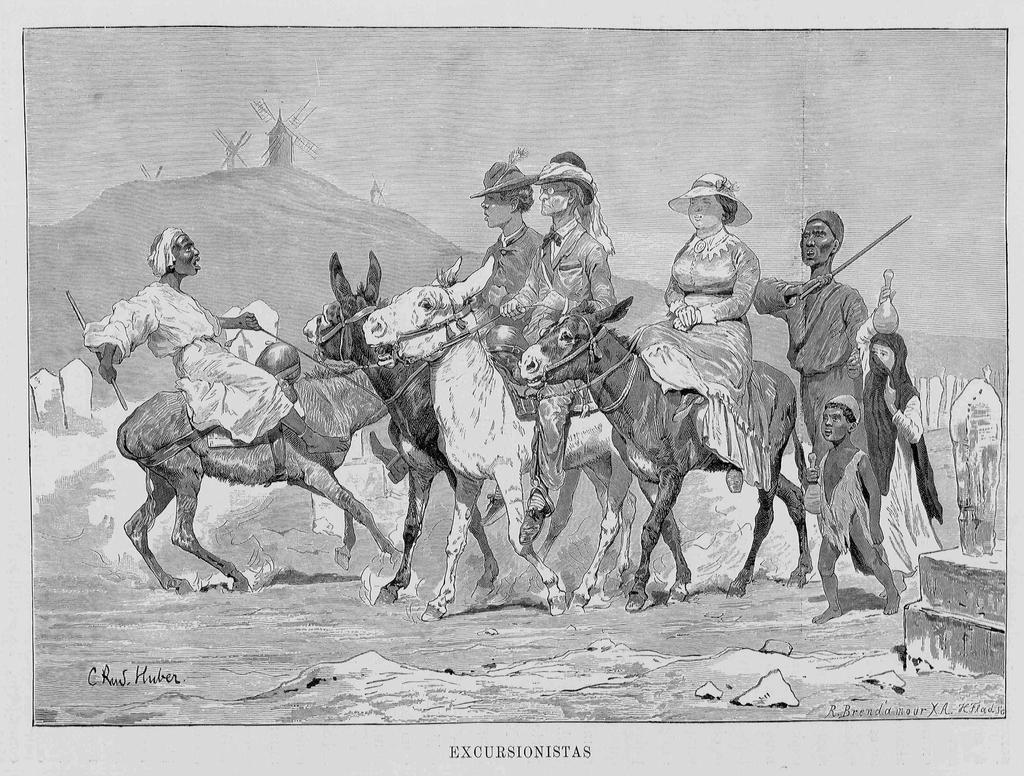In one or two sentences, can you explain what this image depicts? In this picture we can see a paper, in this paper we can see some people are riding horses and three persons are walking, at the bottom there is some text, it is looking like a painting. 